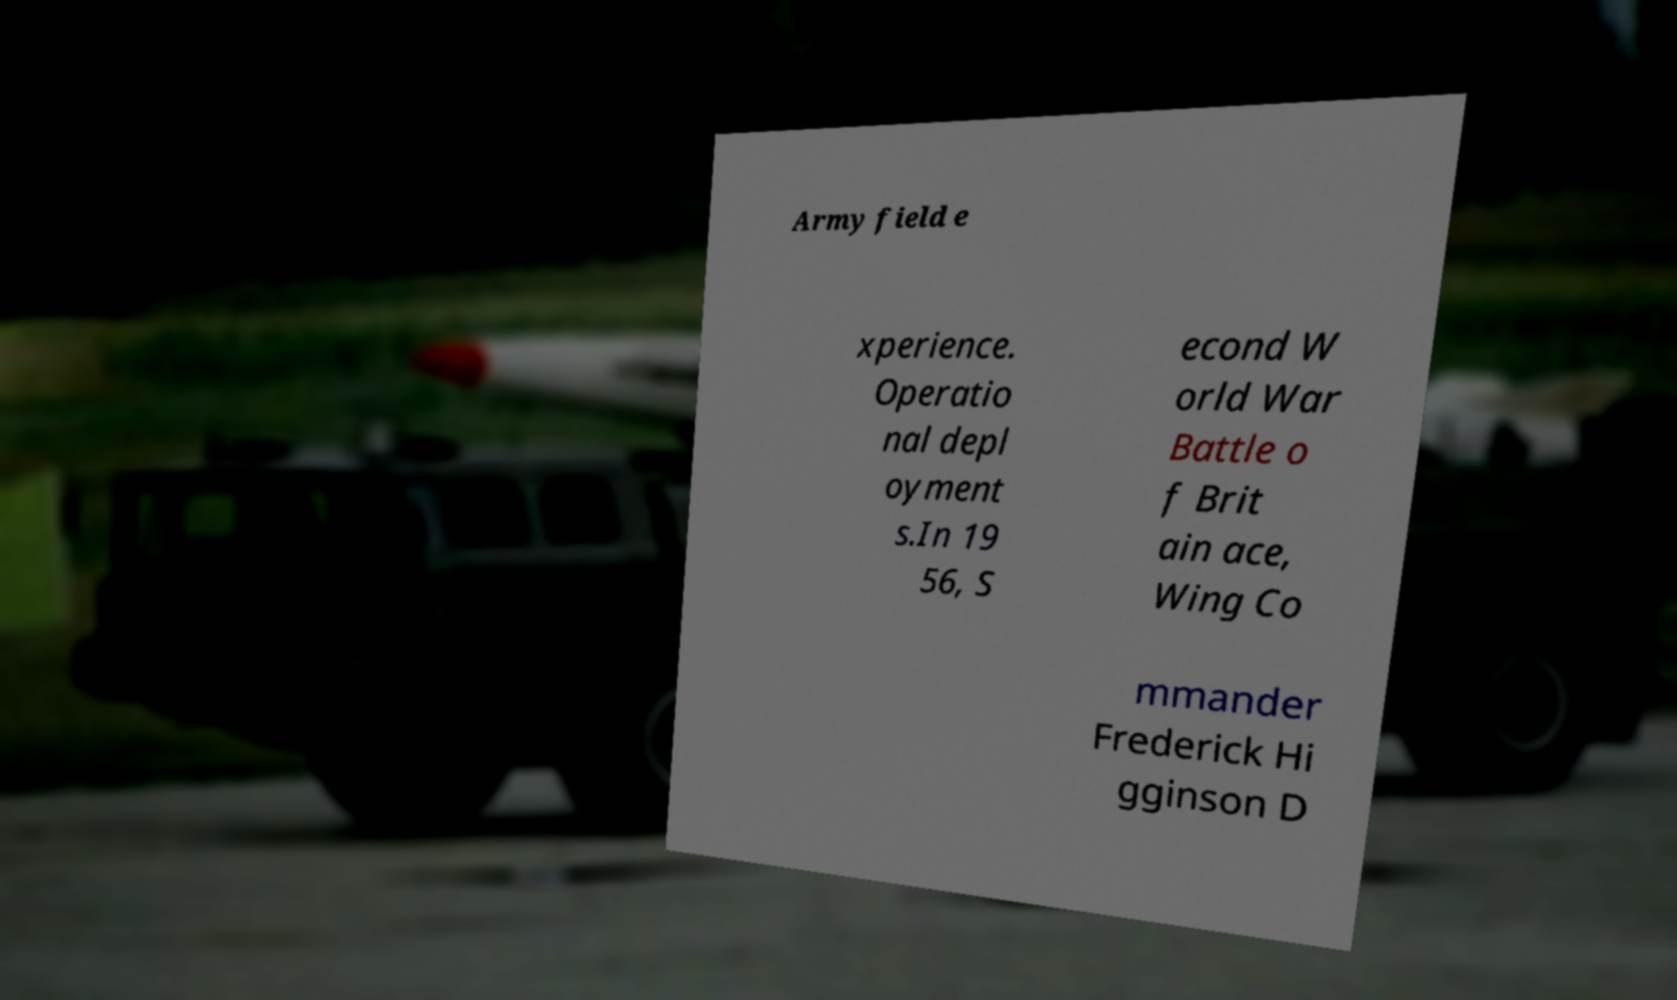Could you extract and type out the text from this image? Army field e xperience. Operatio nal depl oyment s.In 19 56, S econd W orld War Battle o f Brit ain ace, Wing Co mmander Frederick Hi gginson D 